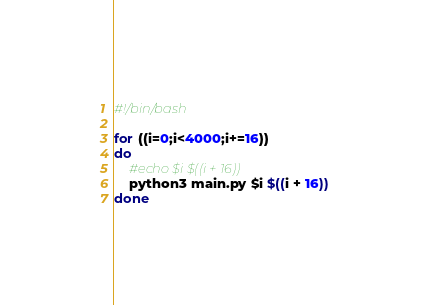Convert code to text. <code><loc_0><loc_0><loc_500><loc_500><_Bash_>#!/bin/bash

for ((i=0;i<4000;i+=16))
do
    #echo $i $((i + 16))
    python3 main.py $i $((i + 16))
done
</code> 